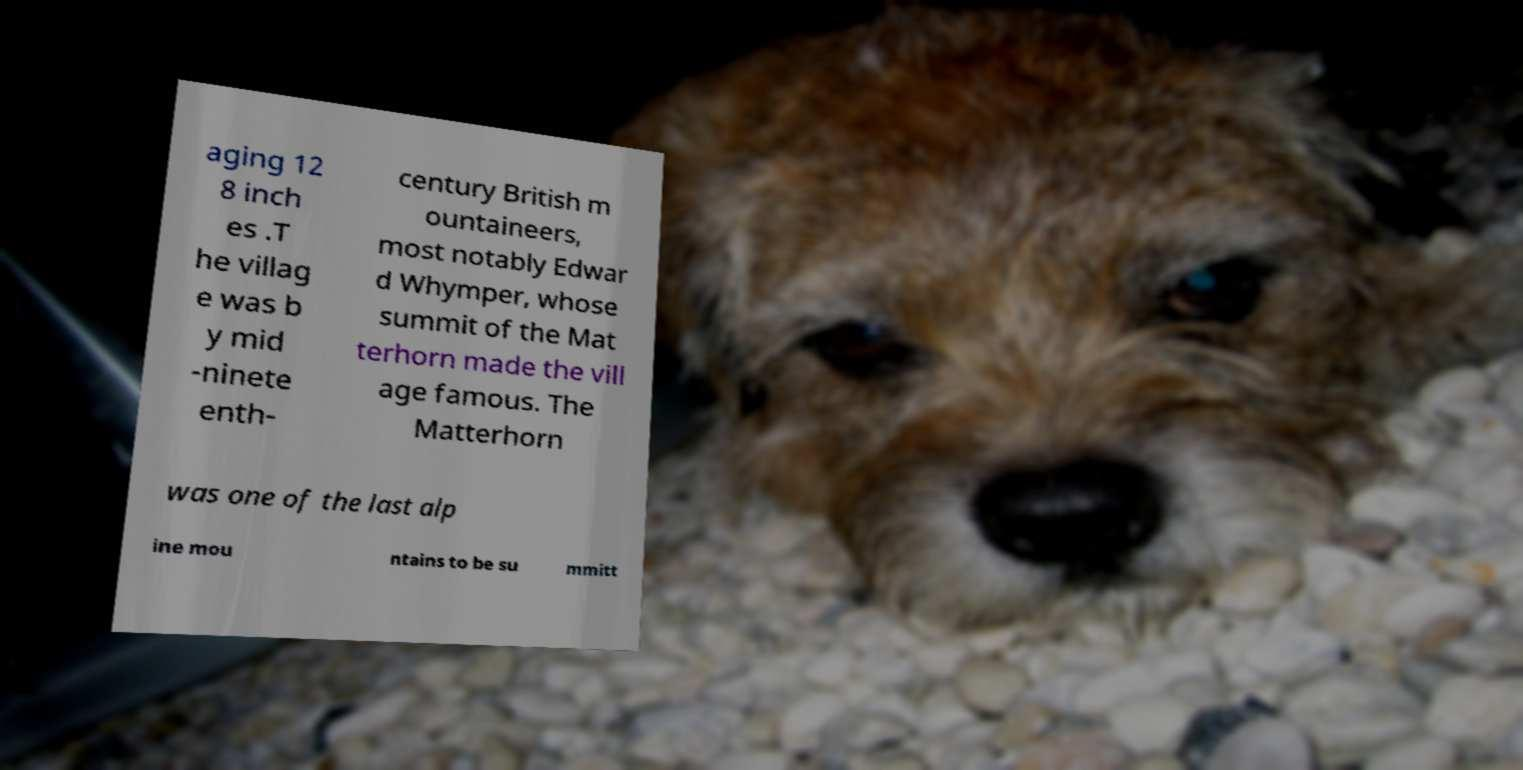Please identify and transcribe the text found in this image. aging 12 8 inch es .T he villag e was b y mid -ninete enth- century British m ountaineers, most notably Edwar d Whymper, whose summit of the Mat terhorn made the vill age famous. The Matterhorn was one of the last alp ine mou ntains to be su mmitt 